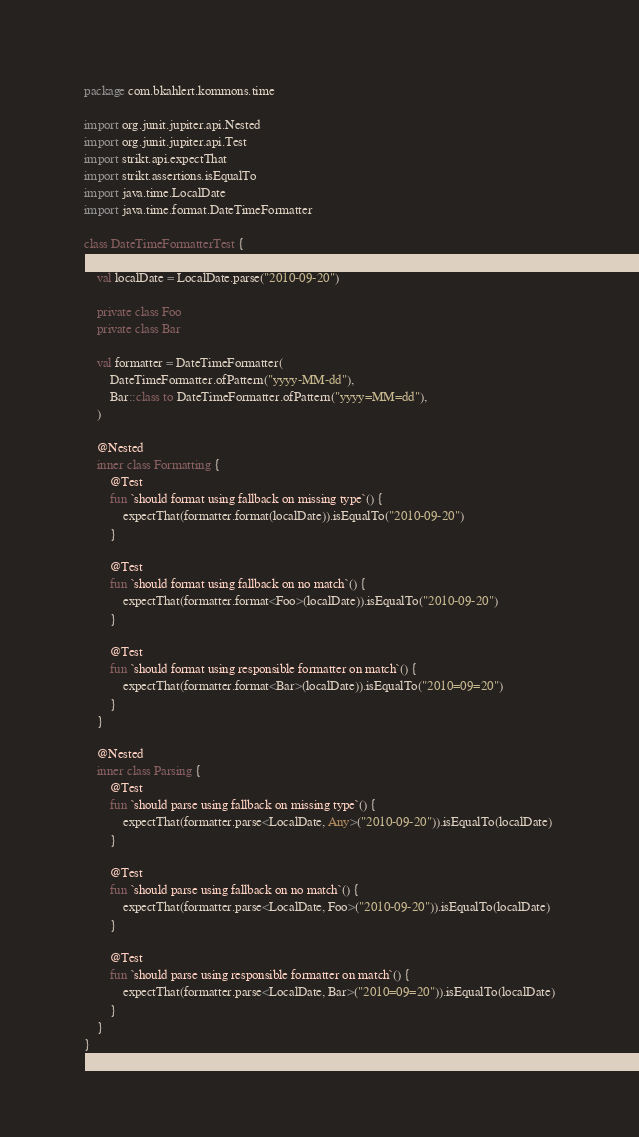<code> <loc_0><loc_0><loc_500><loc_500><_Kotlin_>package com.bkahlert.kommons.time

import org.junit.jupiter.api.Nested
import org.junit.jupiter.api.Test
import strikt.api.expectThat
import strikt.assertions.isEqualTo
import java.time.LocalDate
import java.time.format.DateTimeFormatter

class DateTimeFormatterTest {

    val localDate = LocalDate.parse("2010-09-20")

    private class Foo
    private class Bar

    val formatter = DateTimeFormatter(
        DateTimeFormatter.ofPattern("yyyy-MM-dd"),
        Bar::class to DateTimeFormatter.ofPattern("yyyy=MM=dd"),
    )

    @Nested
    inner class Formatting {
        @Test
        fun `should format using fallback on missing type`() {
            expectThat(formatter.format(localDate)).isEqualTo("2010-09-20")
        }

        @Test
        fun `should format using fallback on no match`() {
            expectThat(formatter.format<Foo>(localDate)).isEqualTo("2010-09-20")
        }

        @Test
        fun `should format using responsible formatter on match`() {
            expectThat(formatter.format<Bar>(localDate)).isEqualTo("2010=09=20")
        }
    }

    @Nested
    inner class Parsing {
        @Test
        fun `should parse using fallback on missing type`() {
            expectThat(formatter.parse<LocalDate, Any>("2010-09-20")).isEqualTo(localDate)
        }

        @Test
        fun `should parse using fallback on no match`() {
            expectThat(formatter.parse<LocalDate, Foo>("2010-09-20")).isEqualTo(localDate)
        }

        @Test
        fun `should parse using responsible formatter on match`() {
            expectThat(formatter.parse<LocalDate, Bar>("2010=09=20")).isEqualTo(localDate)
        }
    }
}
</code> 